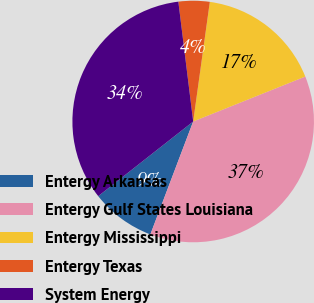Convert chart to OTSL. <chart><loc_0><loc_0><loc_500><loc_500><pie_chart><fcel>Entergy Arkansas<fcel>Entergy Gulf States Louisiana<fcel>Entergy Mississippi<fcel>Entergy Texas<fcel>System Energy<nl><fcel>8.63%<fcel>36.84%<fcel>16.73%<fcel>4.16%<fcel>33.64%<nl></chart> 